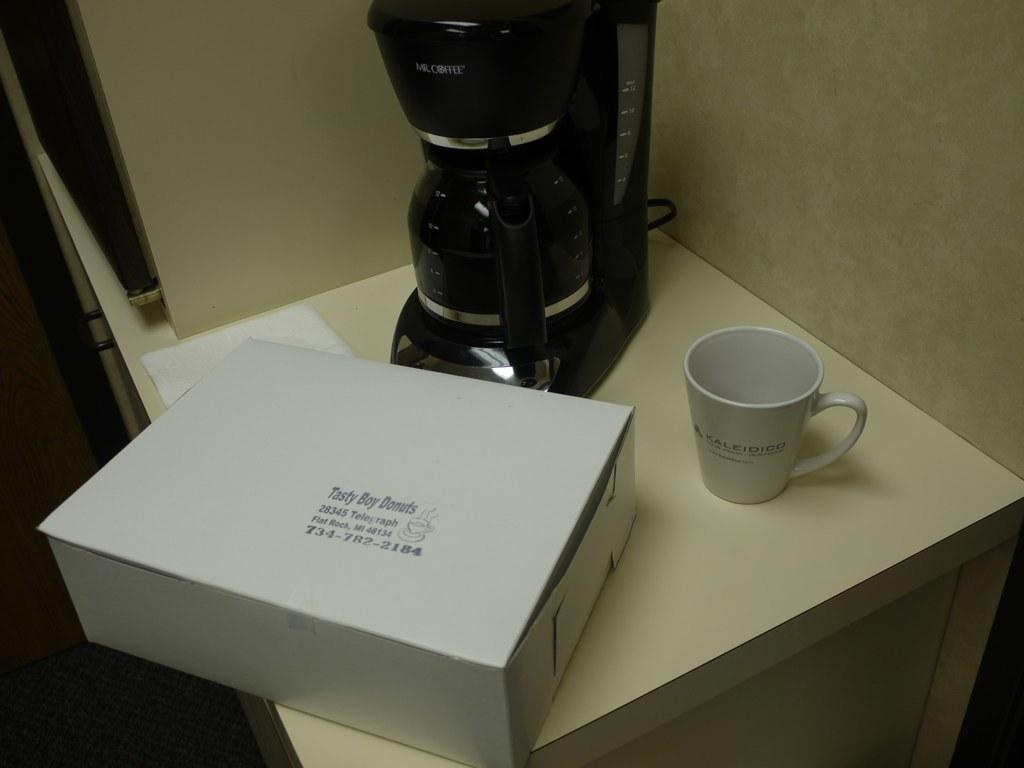<image>
Share a concise interpretation of the image provided. A box of Tasty Boy Doughnuts sitting on the table 